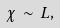Convert formula to latex. <formula><loc_0><loc_0><loc_500><loc_500>\chi \, \sim \, L ,</formula> 